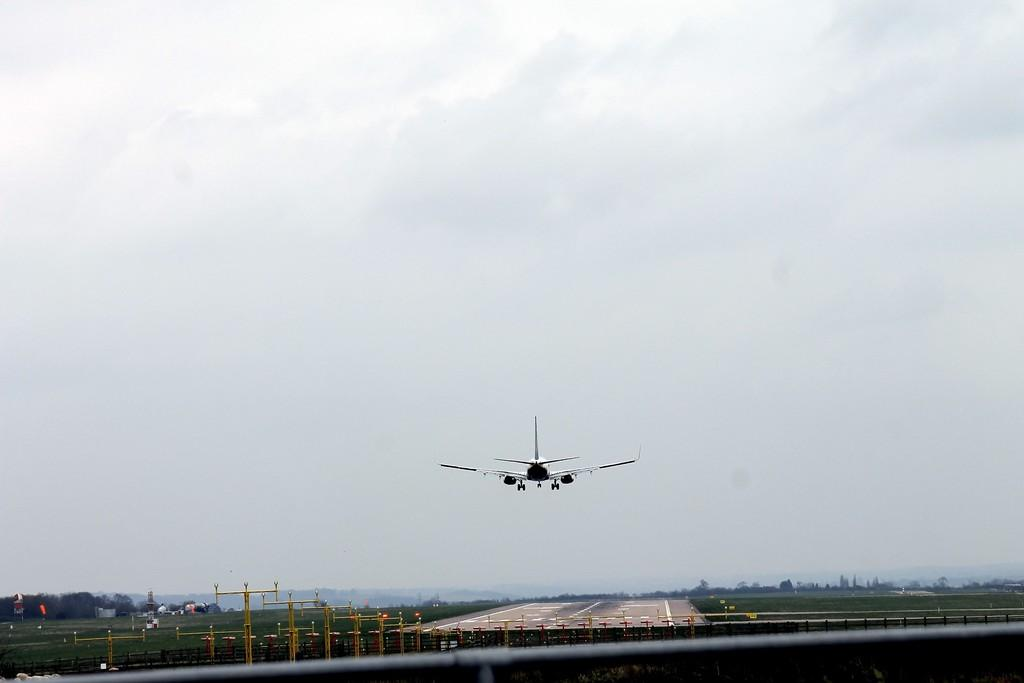What is the main subject of the image? The main subject of the image is an airplane flying in the air. What can be seen on the ground in the image? There is a runway visible in the image. What is visible in the background of the image? The sky is visible in the background of the image. What type of pan is being used to cook food in the image? There is no pan or cooking activity present in the image; it features an airplane flying in the air and a runway. What is the heart rate of the airplane in the image? Airplanes do not have heart rates; they are machines powered by engines. 